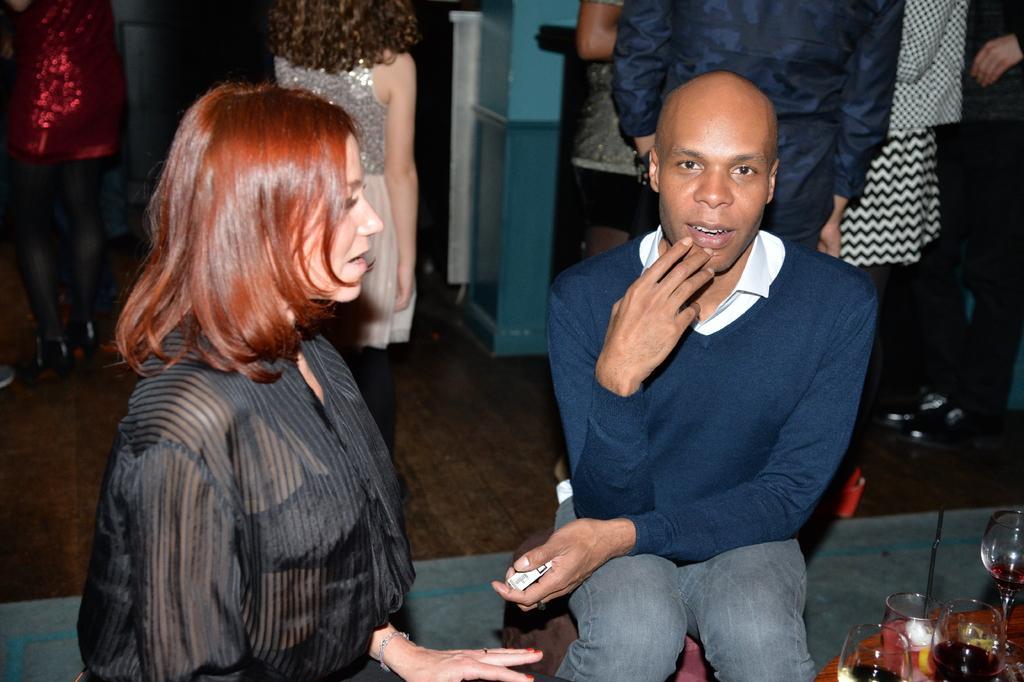Please provide a concise description of this image. In this image I can see two persons sitting. There are wine glasses on a table. And in the background there are few people standing. 